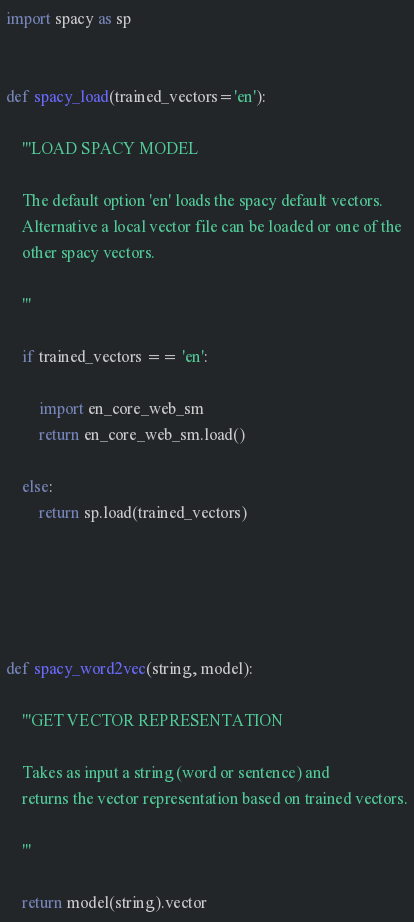<code> <loc_0><loc_0><loc_500><loc_500><_Python_>import spacy as sp


def spacy_load(trained_vectors='en'):

    '''LOAD SPACY MODEL

    The default option 'en' loads the spacy default vectors.
    Alternative a local vector file can be loaded or one of the
    other spacy vectors.

    '''

    if trained_vectors == 'en':

        import en_core_web_sm
        return en_core_web_sm.load()

    else:
        return sp.load(trained_vectors)
    
    
    


def spacy_word2vec(string, model):

    '''GET VECTOR REPRESENTATION

    Takes as input a string (word or sentence) and
    returns the vector representation based on trained vectors.

    '''

    return model(string).vector
</code> 